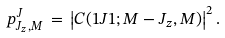<formula> <loc_0><loc_0><loc_500><loc_500>p ^ { J } _ { J _ { z } , M } \, = \, \left | C ( 1 J 1 ; M - J _ { z } , M ) \right | ^ { 2 } .</formula> 